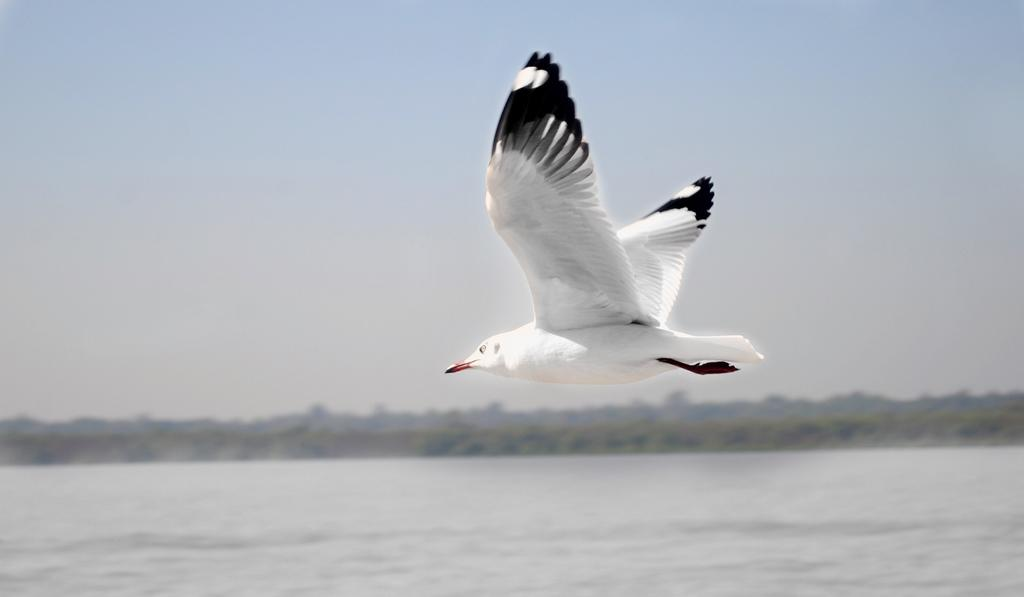What is the main subject of the image? The main subject of the image is a bird flying. Where is the bird flying in the image? The bird is flying over water in the image. What else can be seen in the sky in the image? The sky is visible in the image. Are there any other natural elements present in the image? There may be trees in the image. What type of lumber is the bird using to build its nest in the image? There is no bird building a nest in the image, and no lumber is present. Can you see a cap on the bird's head in the image? No, there is no cap on the bird's head in the image. 